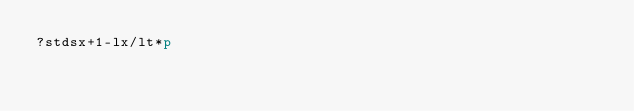Convert code to text. <code><loc_0><loc_0><loc_500><loc_500><_dc_>?stdsx+1-lx/lt*p</code> 